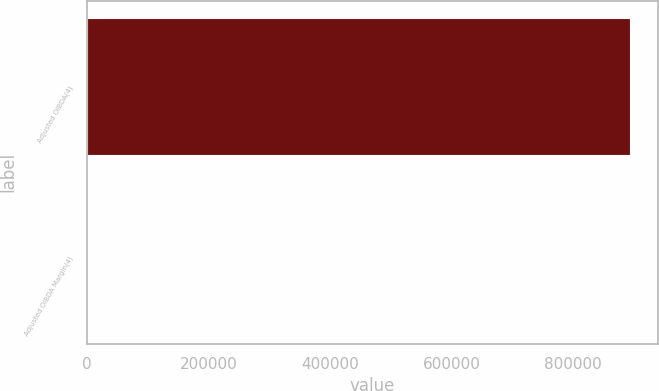<chart> <loc_0><loc_0><loc_500><loc_500><bar_chart><fcel>Adjusted OIBDA(4)<fcel>Adjusted OIBDA Margin(4)<nl><fcel>894581<fcel>29.6<nl></chart> 